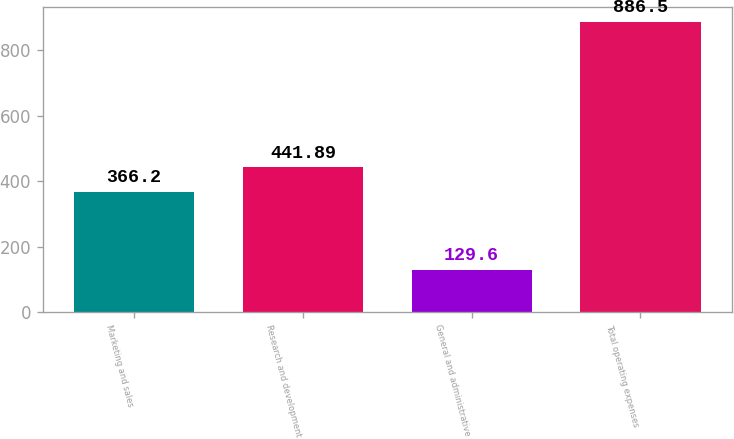Convert chart. <chart><loc_0><loc_0><loc_500><loc_500><bar_chart><fcel>Marketing and sales<fcel>Research and development<fcel>General and administrative<fcel>Total operating expenses<nl><fcel>366.2<fcel>441.89<fcel>129.6<fcel>886.5<nl></chart> 